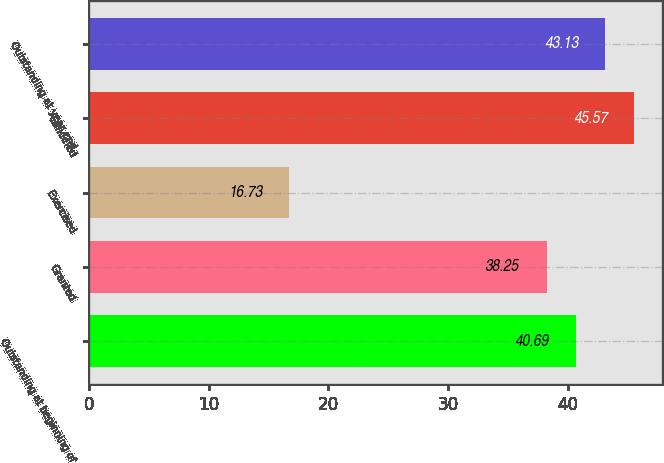Convert chart. <chart><loc_0><loc_0><loc_500><loc_500><bar_chart><fcel>Outstanding at beginning of<fcel>Granted<fcel>Exercised<fcel>Canceled<fcel>Outstanding at year end<nl><fcel>40.69<fcel>38.25<fcel>16.73<fcel>45.57<fcel>43.13<nl></chart> 